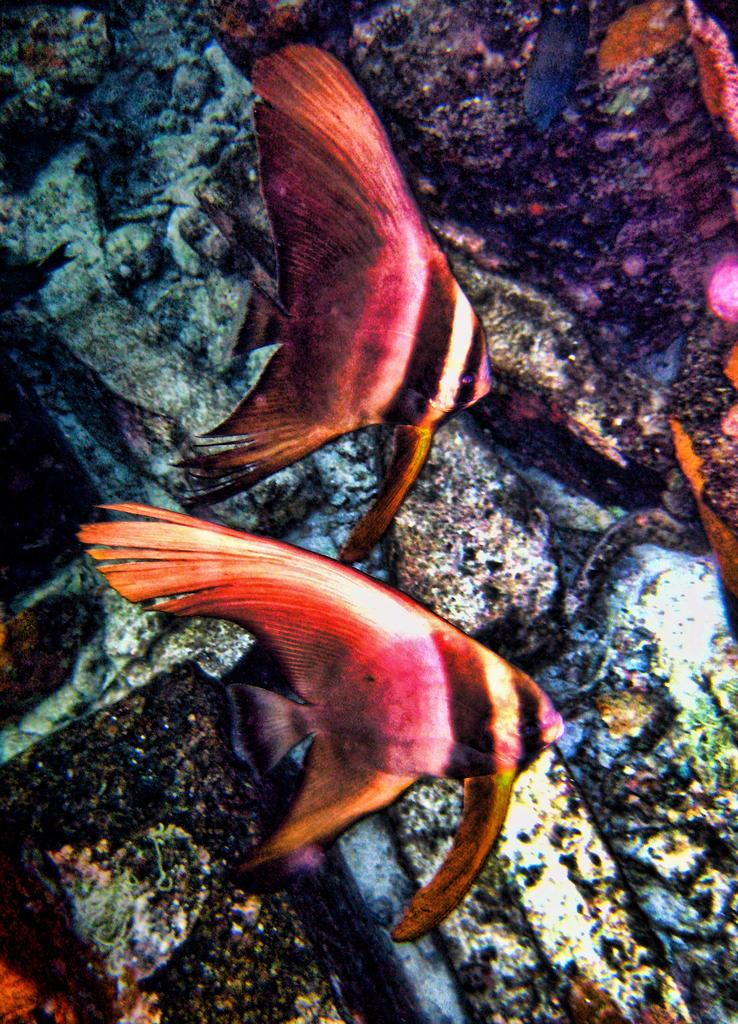What can be observed about the image's appearance? The image appears to be edited. What types of creatures are in the foreground of the image? There are marine creatures in the foreground of the image. What else can be seen in the background of the image? There are other objects in the background of the image. What is the writer's opinion on the rhythm of the marine creatures in the image? There is no writer or opinion on the rhythm of the marine creatures in the image, as the image is a visual representation and does not convey any rhythm or opinion. 